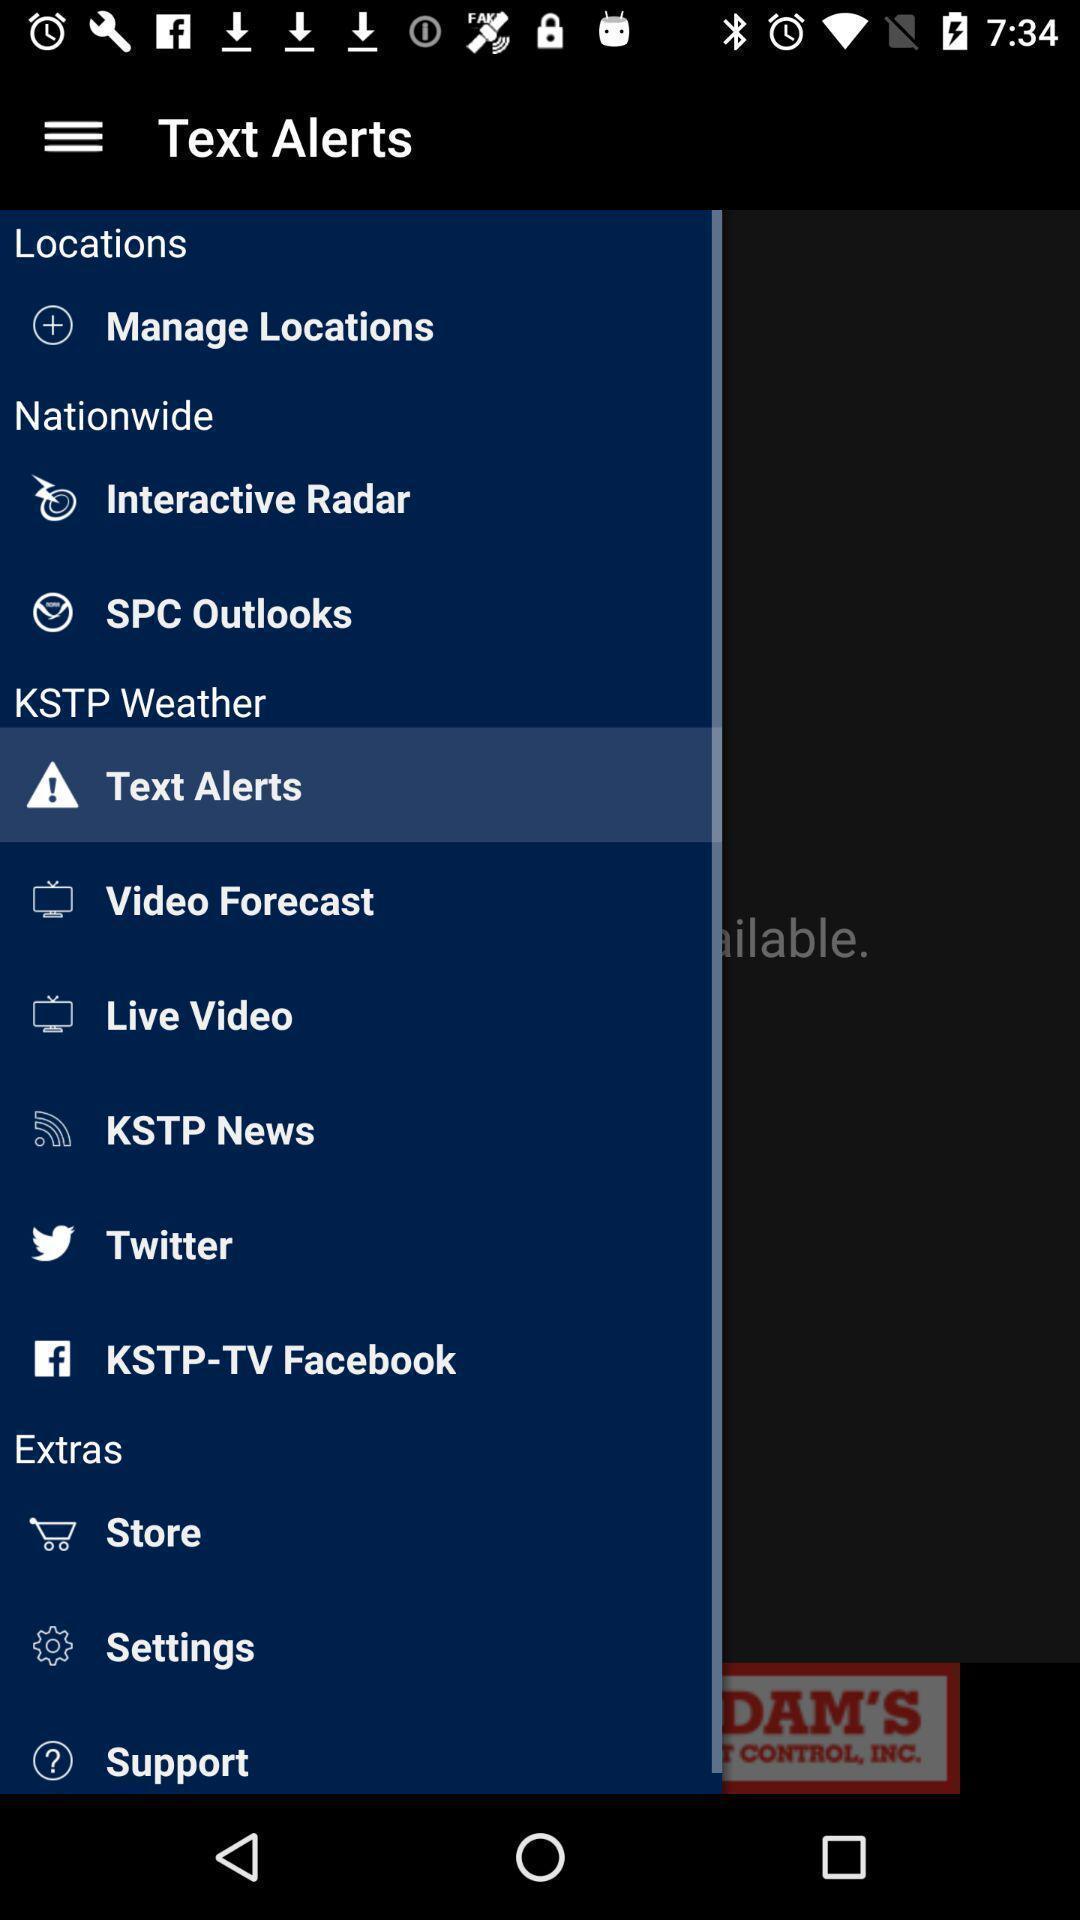Describe the visual elements of this screenshot. Pop up page of text alerts. 